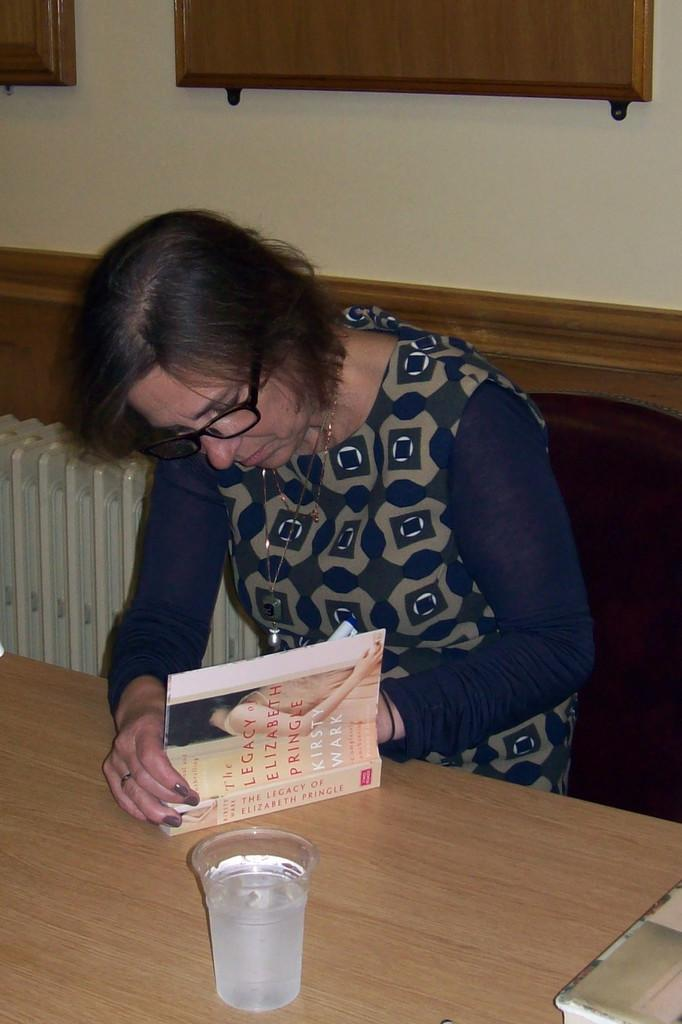Who is the main subject in the image? There is a woman in the image. What is the woman doing in the image? The woman is sitting on a chair and writing in a book. Where is the book located in the image? The book is on a table in front of the woman. What else can be seen in the image? There is a glass of water present in the image. Where is the lunchroom located in the image? There is no lunchroom present in the image. What type of cushion is the woman sitting on in the image? The woman is sitting on a chair, not a cushion, in the image. 